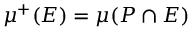Convert formula to latex. <formula><loc_0><loc_0><loc_500><loc_500>\mu ^ { + } ( E ) = \mu ( P \cap E )</formula> 